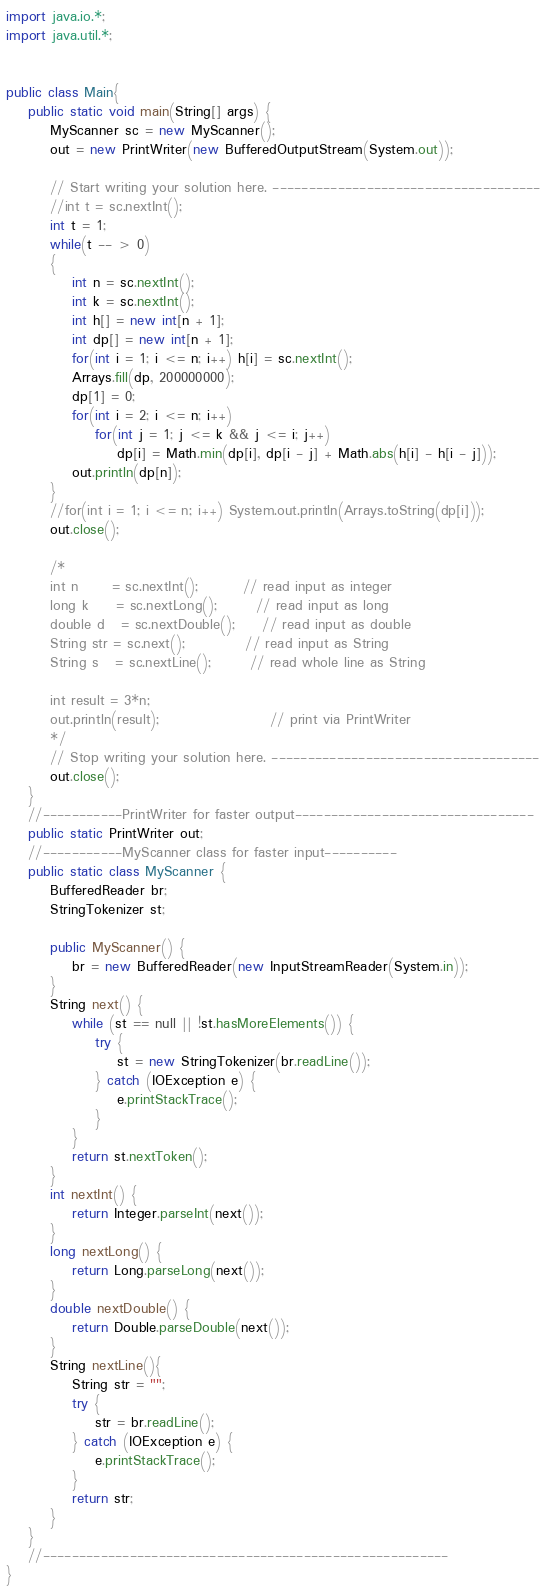Convert code to text. <code><loc_0><loc_0><loc_500><loc_500><_Java_>import java.io.*;
import java.util.*;


public class Main{
    public static void main(String[] args) {
        MyScanner sc = new MyScanner();
        out = new PrintWriter(new BufferedOutputStream(System.out));

        // Start writing your solution here. -------------------------------------
        //int t = sc.nextInt();
        int t = 1;
        while(t -- > 0)
        {
            int n = sc.nextInt();
            int k = sc.nextInt();
            int h[] = new int[n + 1];
            int dp[] = new int[n + 1];
            for(int i = 1; i <= n; i++) h[i] = sc.nextInt();
            Arrays.fill(dp, 200000000);
            dp[1] = 0;
            for(int i = 2; i <= n; i++)
                for(int j = 1; j <= k && j <= i; j++)
                    dp[i] = Math.min(dp[i], dp[i - j] + Math.abs(h[i] - h[i - j]));
            out.println(dp[n]);
        }
        //for(int i = 1; i <= n; i++) System.out.println(Arrays.toString(dp[i]));
        out.close();

        /*
        int n      = sc.nextInt();        // read input as integer
        long k     = sc.nextLong();       // read input as long
        double d   = sc.nextDouble();     // read input as double
        String str = sc.next();           // read input as String
        String s   = sc.nextLine();       // read whole line as String

        int result = 3*n;
        out.println(result);                    // print via PrintWriter
        */
        // Stop writing your solution here. -------------------------------------
        out.close();
    }
    //-----------PrintWriter for faster output---------------------------------
    public static PrintWriter out;
    //-----------MyScanner class for faster input----------
    public static class MyScanner {
        BufferedReader br;
        StringTokenizer st;

        public MyScanner() {
            br = new BufferedReader(new InputStreamReader(System.in));
        }
        String next() {
            while (st == null || !st.hasMoreElements()) {
                try {
                    st = new StringTokenizer(br.readLine());
                } catch (IOException e) {
                    e.printStackTrace();
                }
            }
            return st.nextToken();
        }
        int nextInt() {
            return Integer.parseInt(next());
        }
        long nextLong() {
            return Long.parseLong(next());
        }
        double nextDouble() {
            return Double.parseDouble(next());
        }
        String nextLine(){
            String str = "";
            try {
                str = br.readLine();
            } catch (IOException e) {
                e.printStackTrace();
            }
            return str;
        }
    }
    //--------------------------------------------------------
}</code> 